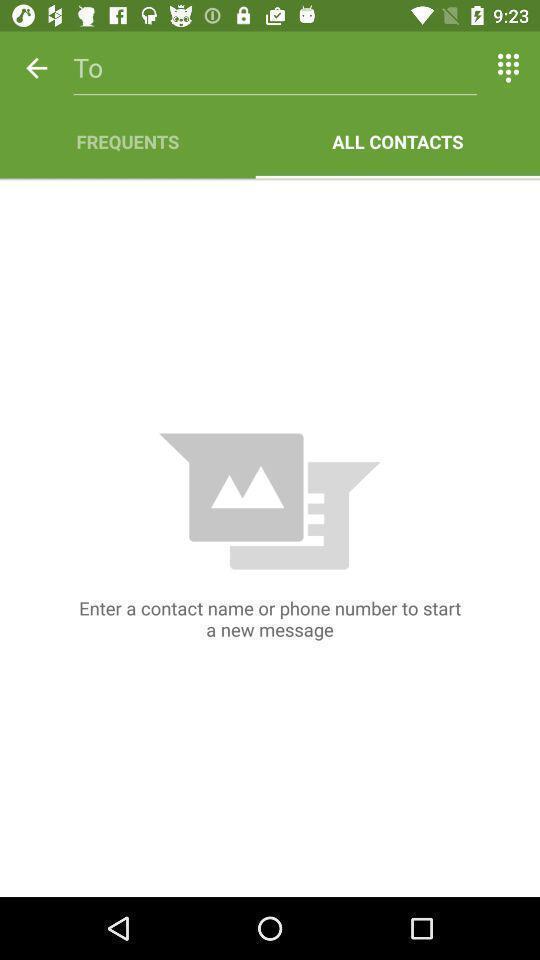Describe this image in words. Screen displaying the all contacts page. 